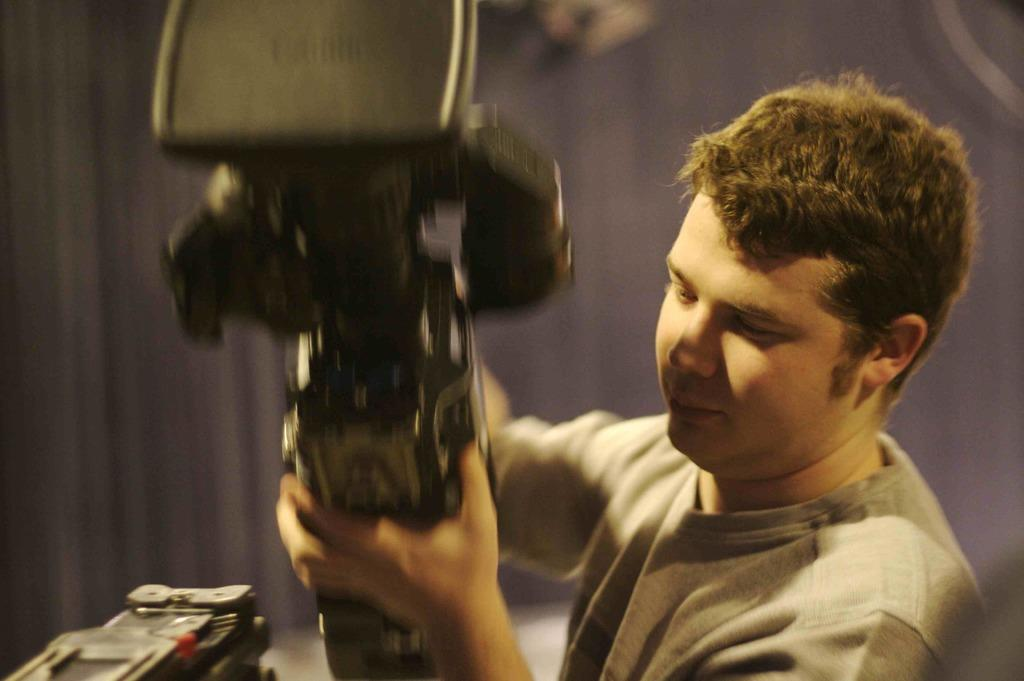Who is in the image? There is a man in the image. What is the man wearing? The man is wearing a grey t-shirt. What is the man holding in his hands? The man is holding a video camera in his hands. What is the man's facial expression? The man is smiling. What can be seen in the background of the image? There is a blue curtain in the background of the image. Is there a volcano visible in the image? No, there is no volcano present in the image. What type of watch is the man wearing in the image? The man is not wearing a watch in the image. 